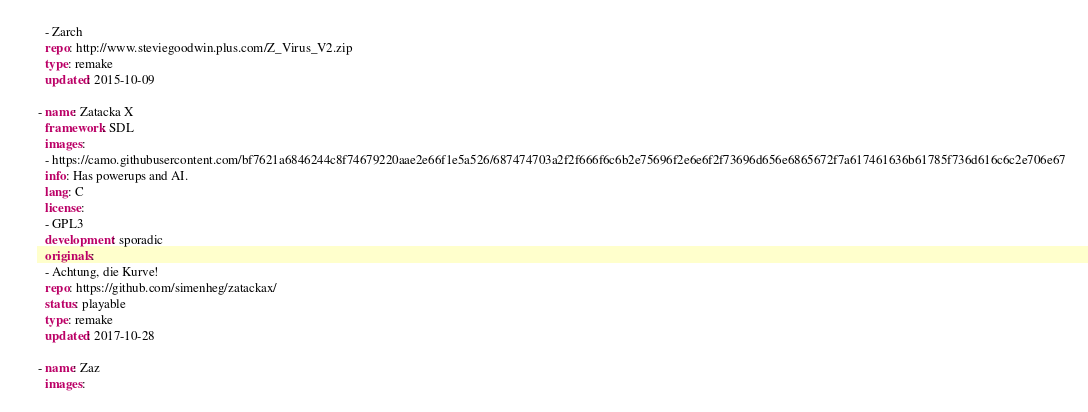<code> <loc_0><loc_0><loc_500><loc_500><_YAML_>  - Zarch
  repo: http://www.steviegoodwin.plus.com/Z_Virus_V2.zip
  type: remake
  updated: 2015-10-09

- name: Zatacka X
  framework: SDL
  images:
  - https://camo.githubusercontent.com/bf7621a6846244c8f74679220aae2e66f1e5a526/687474703a2f2f666f6c6b2e75696f2e6e6f2f73696d656e6865672f7a617461636b61785f736d616c6c2e706e67
  info: Has powerups and AI.
  lang: C
  license:
  - GPL3
  development: sporadic
  originals:
  - Achtung, die Kurve!
  repo: https://github.com/simenheg/zatackax/
  status: playable
  type: remake
  updated: 2017-10-28

- name: Zaz
  images:</code> 